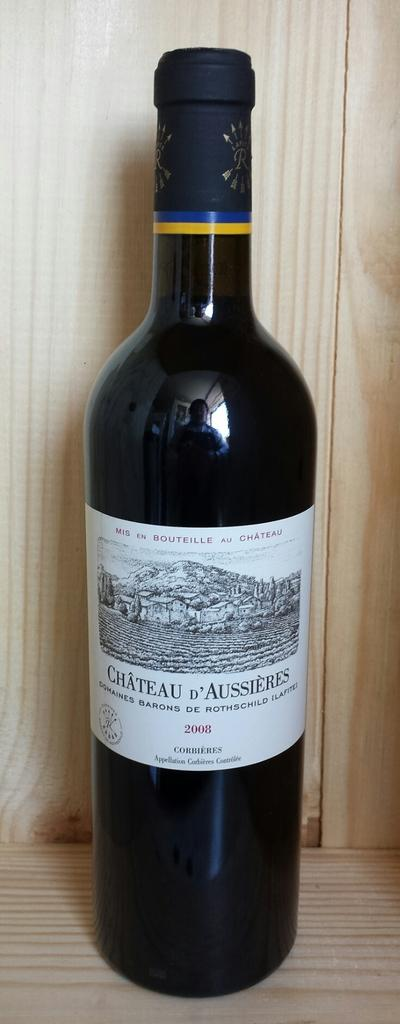Provide a one-sentence caption for the provided image. a wine bottle that has the word Chateau on it. 